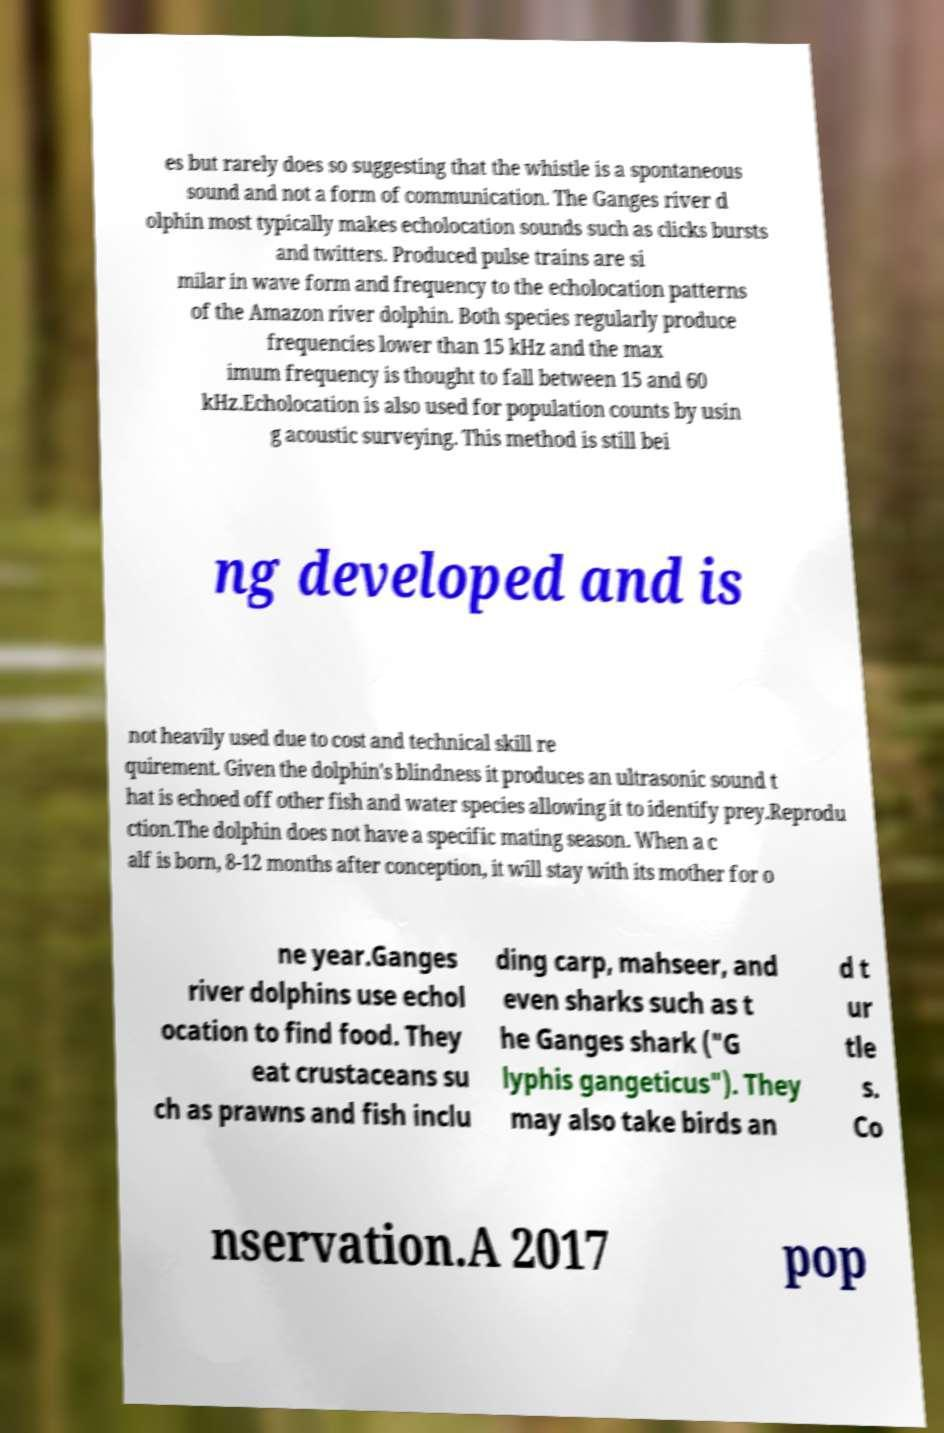Can you accurately transcribe the text from the provided image for me? es but rarely does so suggesting that the whistle is a spontaneous sound and not a form of communication. The Ganges river d olphin most typically makes echolocation sounds such as clicks bursts and twitters. Produced pulse trains are si milar in wave form and frequency to the echolocation patterns of the Amazon river dolphin. Both species regularly produce frequencies lower than 15 kHz and the max imum frequency is thought to fall between 15 and 60 kHz.Echolocation is also used for population counts by usin g acoustic surveying. This method is still bei ng developed and is not heavily used due to cost and technical skill re quirement. Given the dolphin's blindness it produces an ultrasonic sound t hat is echoed off other fish and water species allowing it to identify prey.Reprodu ction.The dolphin does not have a specific mating season. When a c alf is born, 8-12 months after conception, it will stay with its mother for o ne year.Ganges river dolphins use echol ocation to find food. They eat crustaceans su ch as prawns and fish inclu ding carp, mahseer, and even sharks such as t he Ganges shark ("G lyphis gangeticus"). They may also take birds an d t ur tle s. Co nservation.A 2017 pop 